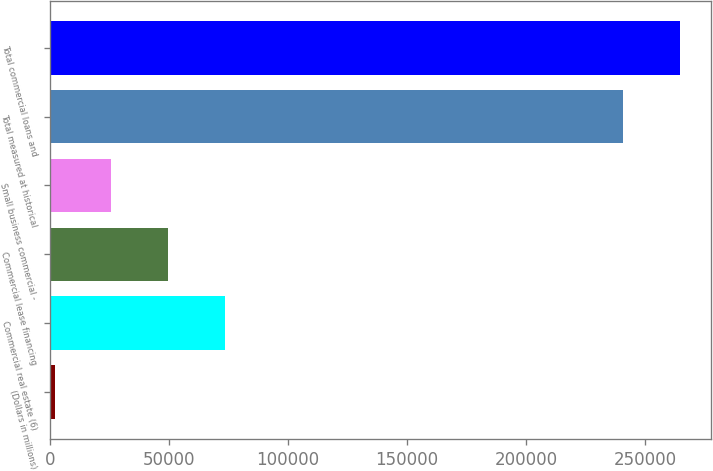<chart> <loc_0><loc_0><loc_500><loc_500><bar_chart><fcel>(Dollars in millions)<fcel>Commercial real estate (6)<fcel>Commercial lease financing<fcel>Small business commercial -<fcel>Total measured at historical<fcel>Total commercial loans and<nl><fcel>2006<fcel>73639.7<fcel>49761.8<fcel>25883.9<fcel>240785<fcel>264663<nl></chart> 